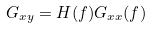Convert formula to latex. <formula><loc_0><loc_0><loc_500><loc_500>G _ { x y } = H ( f ) G _ { x x } ( f )</formula> 